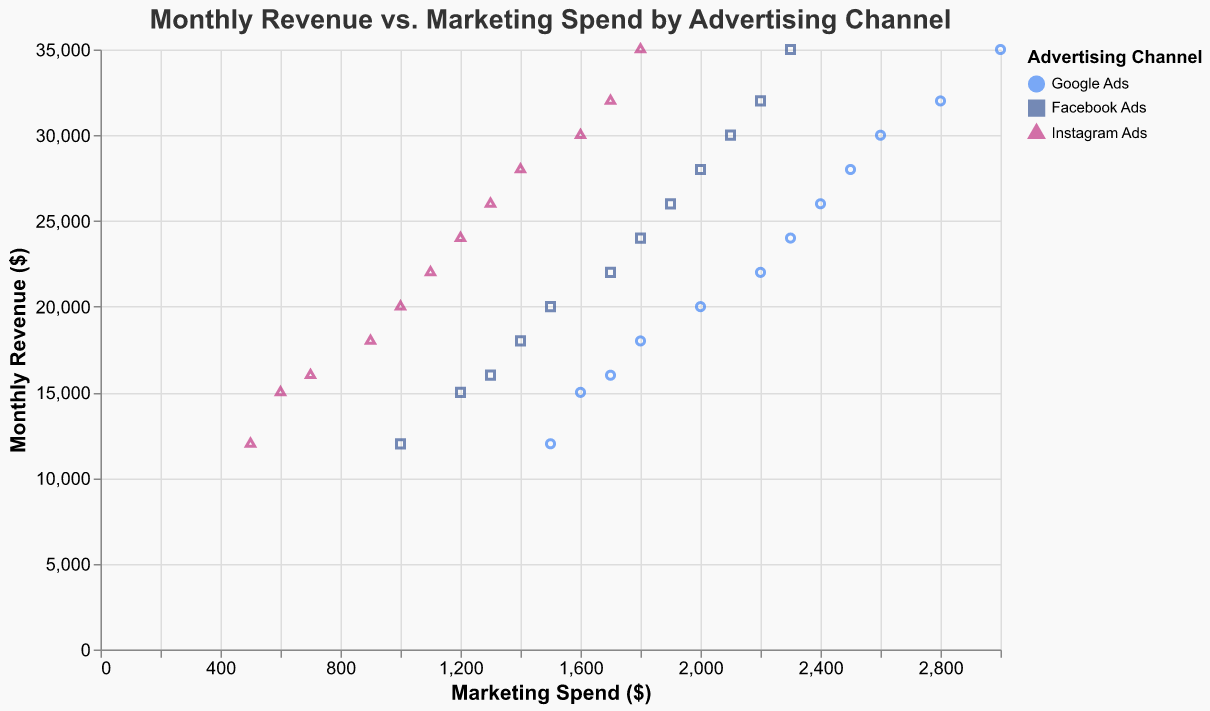What's the title of the figure? The title of the figure is displayed at the top and reads "Monthly Revenue vs. Marketing Spend by Advertising Channel".
Answer: Monthly Revenue vs. Marketing Spend by Advertising Channel How many different advertising channels are displayed in the figure? The legend indicates the three different advertising channels: Google Ads, Facebook Ads, and Instagram Ads.
Answer: 3 Which month had the highest revenue? The tooltip over the highest data point shows that December had the highest revenue of $35,000.
Answer: December What is the relationship between marketing spend and revenue according to the trend line? The trend line, with its upward slope, suggests a positive correlation between marketing spend and revenue, meaning that as marketing spend increases, revenue tends to increase as well.
Answer: Positive correlation Which advertising channel had the lowest marketing spend in January? By examining the data points in January, Instagram Ads had the lowest marketing spend of $500.
Answer: Instagram Ads What is the average marketing spend for Facebook Ads in December? The marketing spend for Facebook Ads in December is $2300. Since there is only one data point for Facebook Ads in December, the average is $2300.
Answer: $2300 How does the marketing spend in April for Google Ads compare to Facebook Ads? In April, the marketing spend for Google Ads is $1800, and for Facebook Ads, it is $1400. Google Ads spend is $400 more than Facebook Ads.
Answer: $400 more What is the marketing spend range for Instagram Ads across all months? The lowest marketing spend for Instagram Ads is $500 in January, and the highest is $1800 in December. The range is $1800 - $500 = $1300.
Answer: $1300 Does the data suggest that Google Ads generally require more marketing spend than Instagram Ads? Across all months, Google Ads consistently have higher marketing spend values compared to Instagram Ads, supporting that Google Ads generally require more marketing spend.
Answer: Yes Which advertising channel has the most clustered data points? By observing the scatter plot, Google Ads show a closer clustering of data points compared to Facebook and Instagram Ads, indicating less variability in their marketing spend.
Answer: Google Ads 